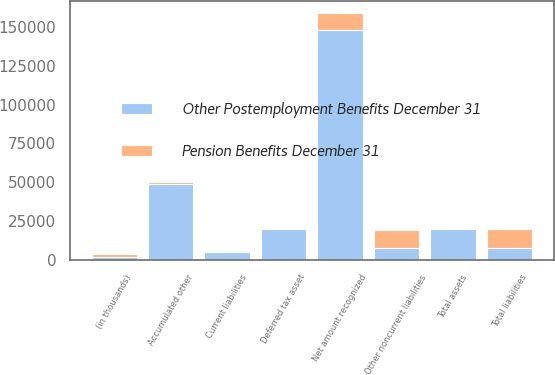<chart> <loc_0><loc_0><loc_500><loc_500><stacked_bar_chart><ecel><fcel>(in thousands)<fcel>Deferred tax asset<fcel>Total assets<fcel>Current liabilities<fcel>Other noncurrent liabilities<fcel>Total liabilities<fcel>Accumulated other<fcel>Net amount recognized<nl><fcel>Other Postemployment Benefits December 31<fcel>2013<fcel>19618<fcel>19641<fcel>5097<fcel>7733.5<fcel>7733.5<fcel>48957<fcel>148320<nl><fcel>Pension Benefits December 31<fcel>2013<fcel>605<fcel>605<fcel>491<fcel>11445<fcel>11936<fcel>961<fcel>10370<nl></chart> 